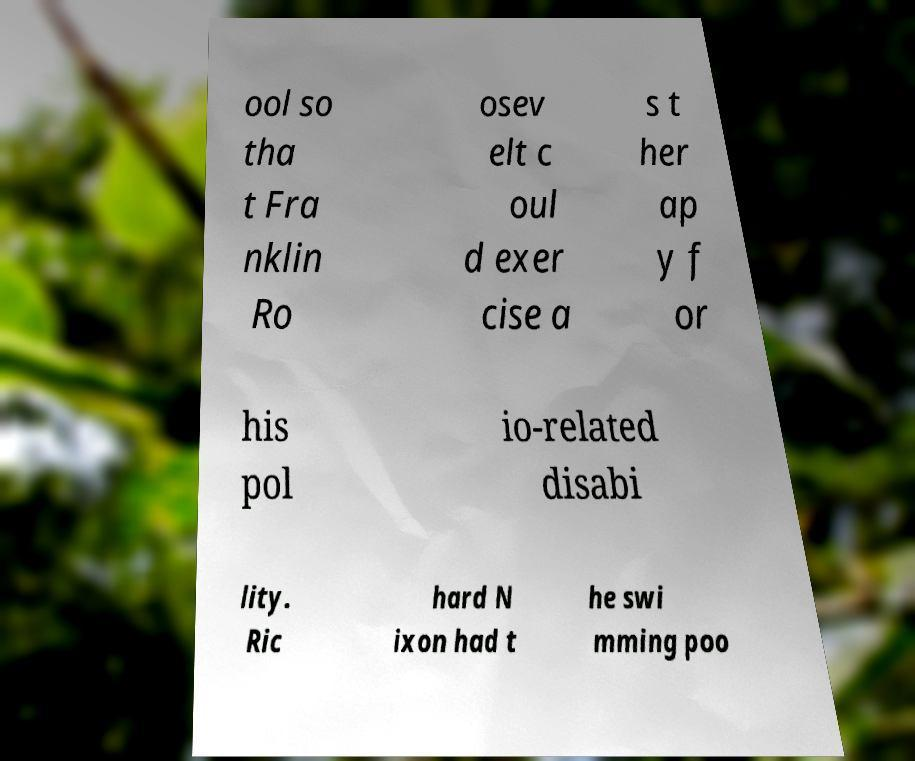Can you read and provide the text displayed in the image?This photo seems to have some interesting text. Can you extract and type it out for me? ool so tha t Fra nklin Ro osev elt c oul d exer cise a s t her ap y f or his pol io-related disabi lity. Ric hard N ixon had t he swi mming poo 